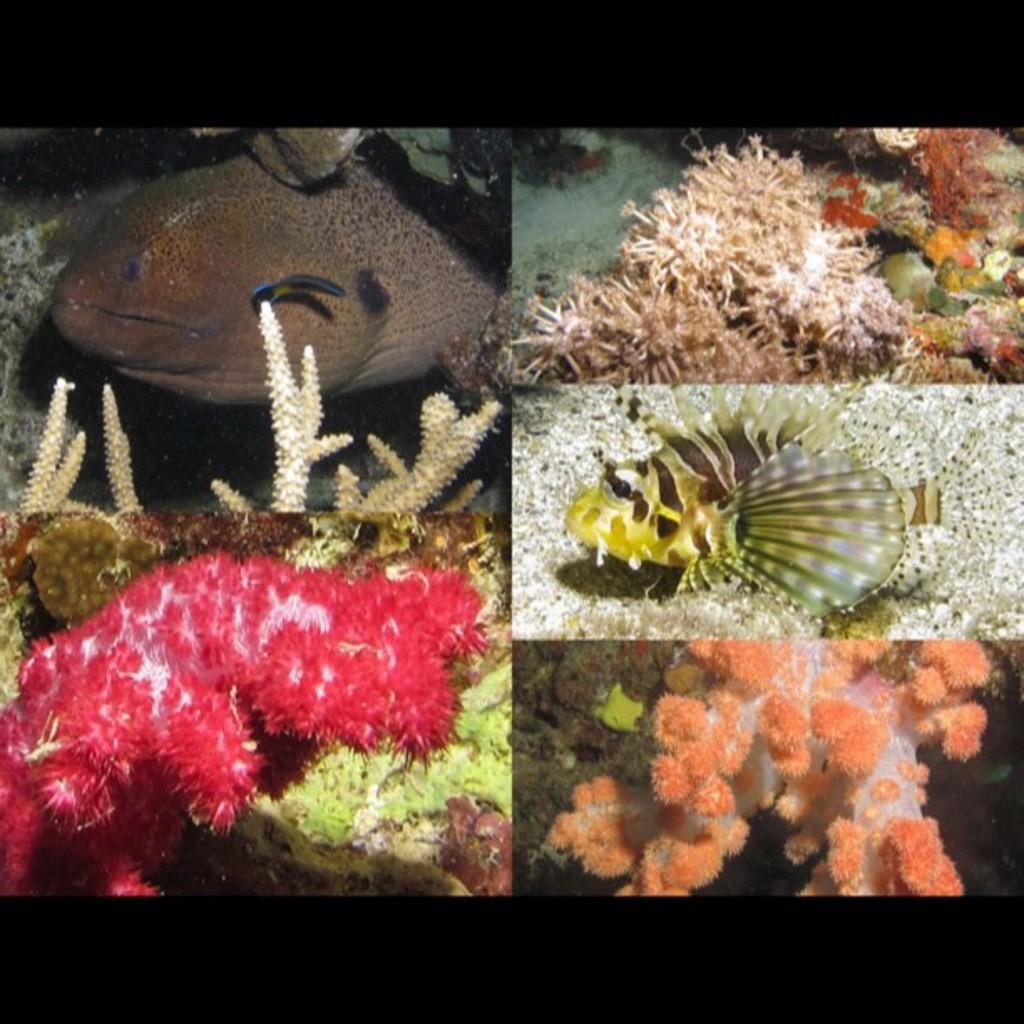What type of animals can be seen in the image? There are coral reef fishes in the image. What type of tool is the cook using to prepare the fish in the image? There is no cook or tool present in the image; it features coral reef fishes. What type of material is the pin made of in the image? There is no pin present in the image; it features coral reef fishes. 